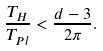<formula> <loc_0><loc_0><loc_500><loc_500>\frac { T _ { H } } { T _ { P l } } < \frac { d - 3 } { 2 \pi } .</formula> 